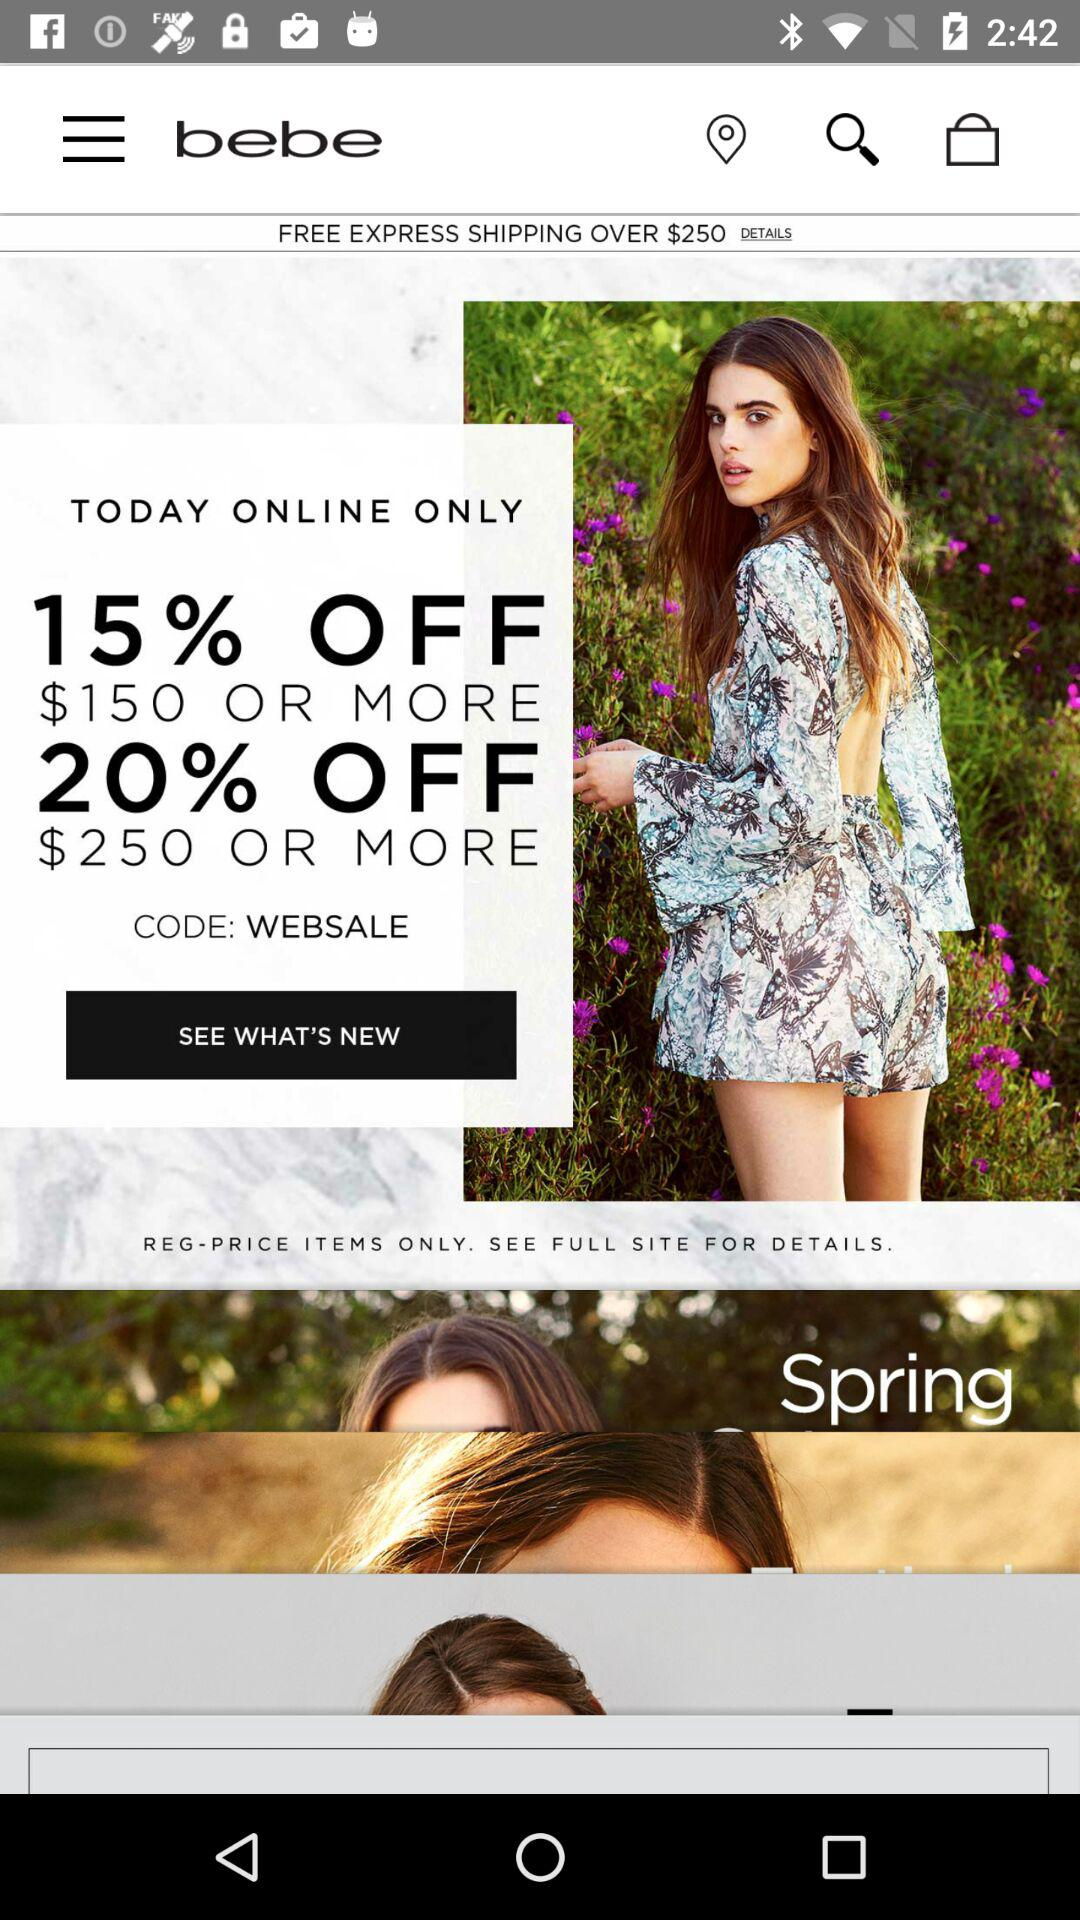What is the name of the application? The name of the application is "bebe". 